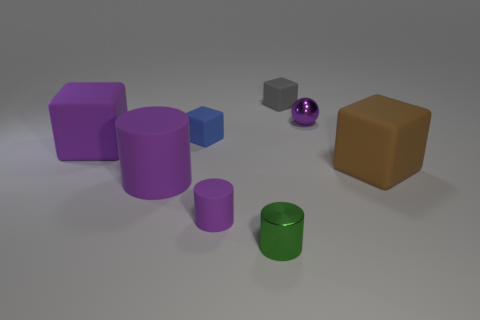The metallic cylinder that is the same size as the gray rubber block is what color?
Ensure brevity in your answer.  Green. What is the shape of the purple object that is both behind the large brown object and left of the purple metallic ball?
Provide a short and direct response. Cube. There is a matte block that is right of the tiny cube that is to the right of the small blue matte thing; what size is it?
Ensure brevity in your answer.  Large. What number of other large rubber cylinders have the same color as the large rubber cylinder?
Make the answer very short. 0. How many other objects are the same size as the blue rubber object?
Offer a very short reply. 4. There is a purple thing that is behind the small purple rubber cylinder and on the right side of the big purple matte cylinder; what size is it?
Provide a short and direct response. Small. How many other large matte things have the same shape as the blue rubber thing?
Your answer should be very brief. 2. What material is the small gray cube?
Your response must be concise. Rubber. Does the blue matte thing have the same shape as the tiny green metallic thing?
Your response must be concise. No. Is there a tiny cyan thing that has the same material as the blue object?
Provide a succinct answer. No. 